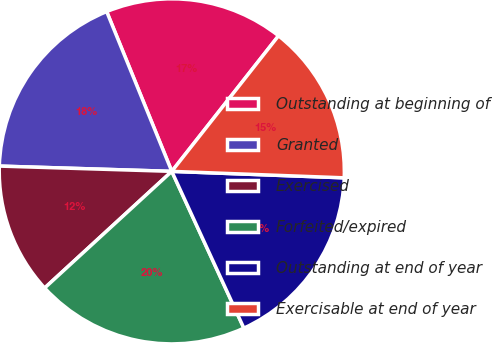Convert chart to OTSL. <chart><loc_0><loc_0><loc_500><loc_500><pie_chart><fcel>Outstanding at beginning of<fcel>Granted<fcel>Exercised<fcel>Forfeited/expired<fcel>Outstanding at end of year<fcel>Exercisable at end of year<nl><fcel>16.77%<fcel>18.35%<fcel>12.3%<fcel>20.04%<fcel>17.54%<fcel>14.98%<nl></chart> 